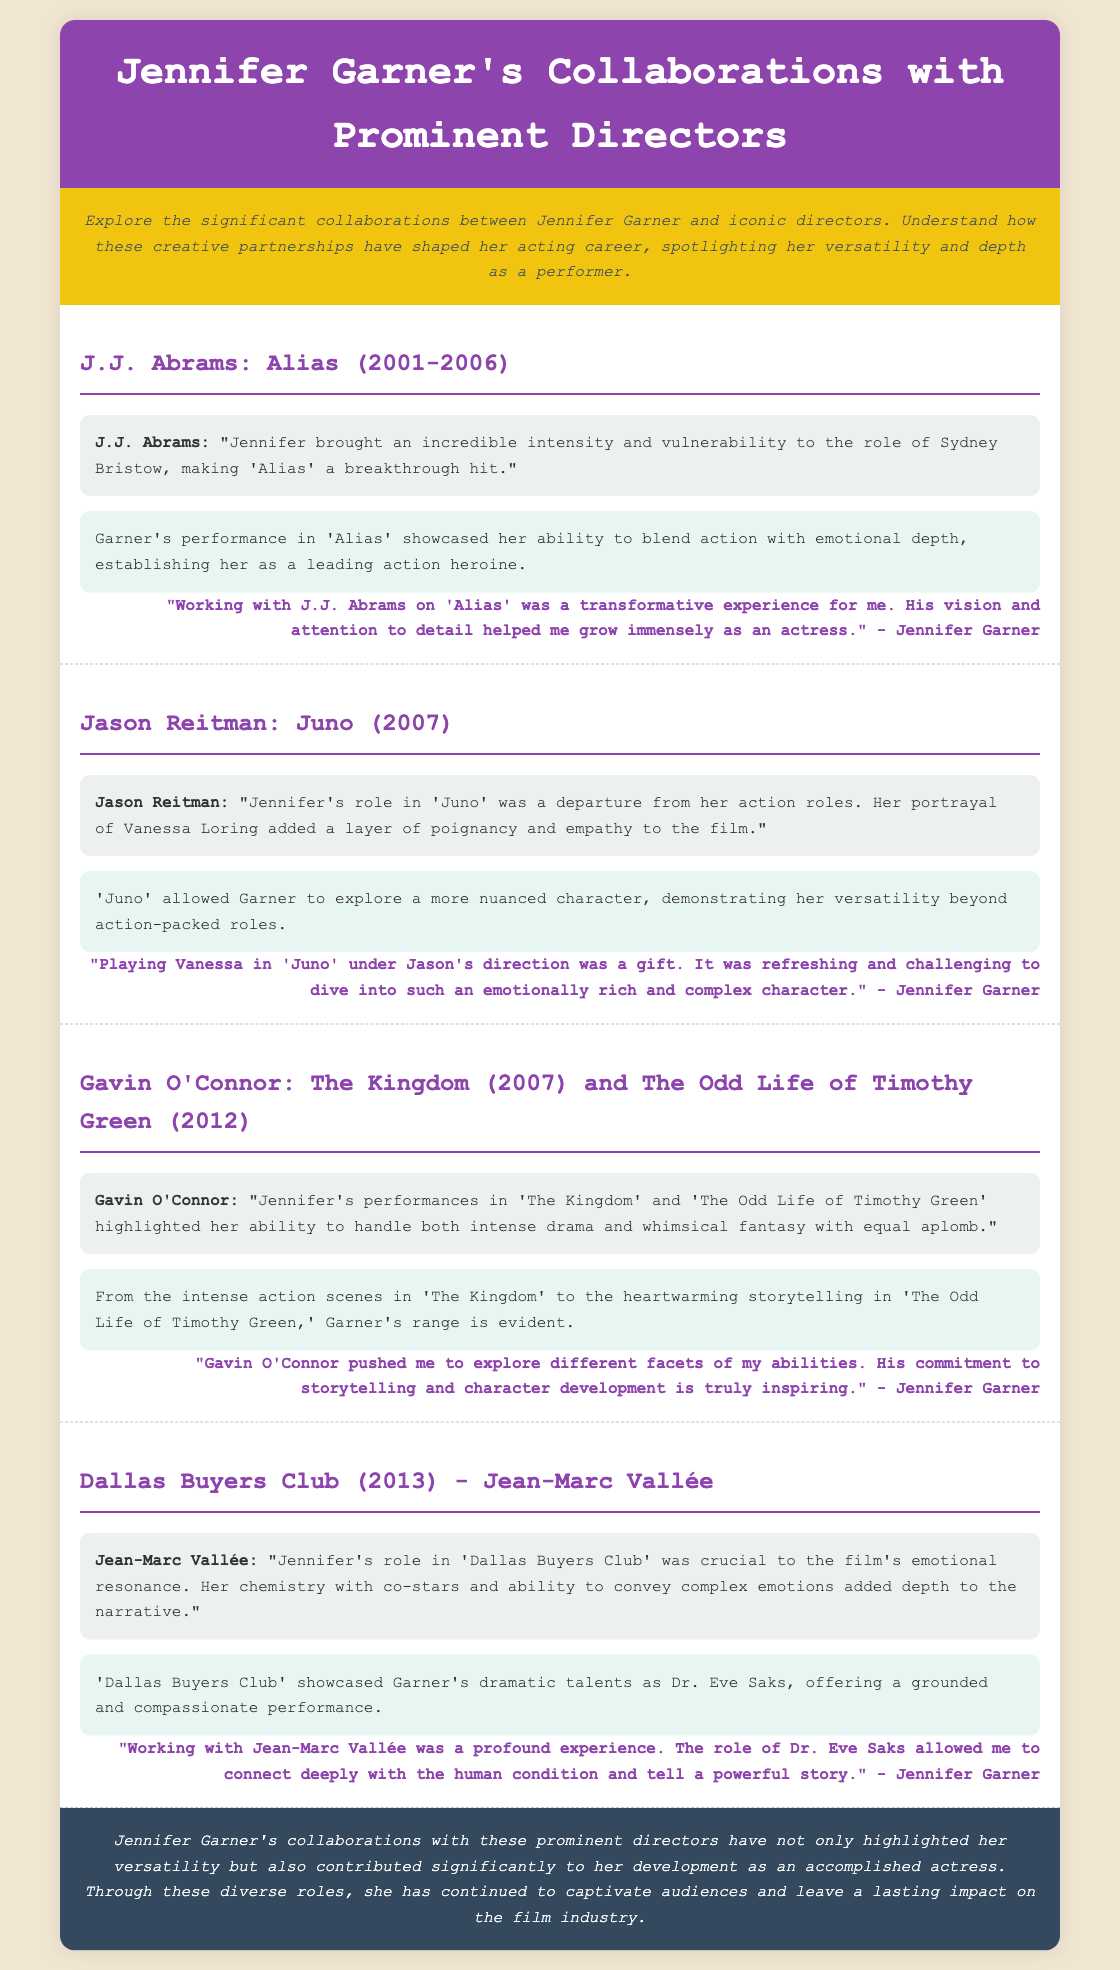What is the title of the presentation? The title of the presentation is stated in the header of the document.
Answer: Jennifer Garner's Collaborations with Prominent Directors Who directed 'Juno'? The director's name is mentioned in the section about the film 'Juno'.
Answer: Jason Reitman In which year did 'Alias' first air? The year 'Alias' first aired is specified in the section regarding J.J. Abrams.
Answer: 2001 What character did Jennifer Garner portray in 'Dallas Buyers Club'? The character Jennifer Garner portrayed is mentioned in the section about the film 'Dallas Buyers Club'.
Answer: Dr. Eve Saks What film showcased Garner's ability to blend action with emotional depth? The specific film that highlighted this aspect of Garner's acting is mentioned in the section on J.J. Abrams.
Answer: Alias Which director stated that Jennifer's role in 'Juno' added a layer of poignancy and empathy? The name of the director who made this statement is found in the section discussing 'Juno'.
Answer: Jason Reitman What is the concluding statement about Garner's collaborations? The conclusion summarizes her overall impact and development based on her collaborations.
Answer: contributed significantly to her development as an accomplished actress How many films directed by Gavin O'Connor are mentioned? The number of films by Gavin O'Connor listed in the document is given in the respective section.
Answer: Two 